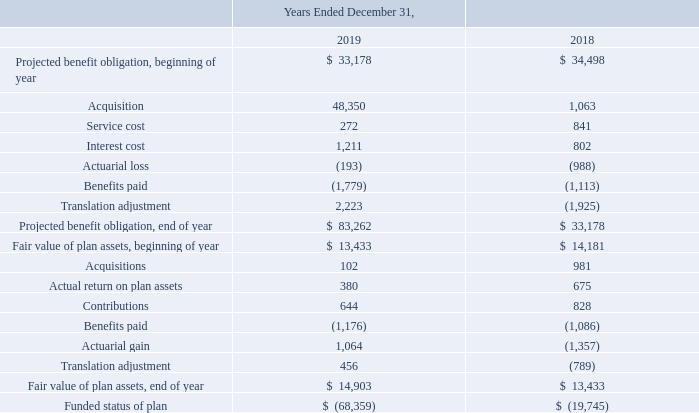Defined Benefit Plan
We maintain defined benefit pension plans for certain of our non-U.S. employees in the U.K., Germany, and Philippines. Each plan is managed locally and in accordance with respective local laws and regulations.
In order to measure the expense and related benefit obligation, various assumptions are made including discount rates used to value the obligation, expected return on plan assets used to fund these expenses and estimated future inflation rates. These assumptions are based on historical experience as well as facts and circumstances. An actuarial analysis is used to measure the expense and liability associated with pension benefits.
In connection with the acquisition of Artesyn in September of 2019, the Company acquired certain pension plans and, as a result, started including the related balances in its Consolidated Balance Sheets at December 31, 2019 and the expenses attributable to these plans for the period from September 10, 2019 to December 31, 2019 in its Consolidated Statement of Operations. See Note 2. Business Acquisitions for more details on this transaction.
ADVANCED ENERGY INDUSTRIES, INC. NOTES TO CONSOLIDATED FINANCIAL STATEMENTS – (continued) (in thousands, except per share amounts)
The information provided below includes one pension plan which is part of discontinued operations. As such, all related liabilities and expenses are reported in discontinued operations in the Company’s Consolidated Balance Sheets and Consolidated Statements of Operations for all periods presented.
The Company’s projected benefit obligation and plan assets for defined benefit pension plans at December 31, 2019 and 2018 and the related assumptions used to determine the related liabilities are as follows:
Where does the company report all related liabilities and expenses to discontinued operations? In discontinued operations in the company’s consolidated balance sheets and consolidated statements of operations for all periods presented. What was the acquisition in 2019?
Answer scale should be: thousand. 48,350. What was the service cost in 2018?
Answer scale should be: thousand. 841. What was the change in service cost between 2018 and 2019?
Answer scale should be: thousand. 272-841
Answer: -569. What was the change in interest cost between 2018 and 2019?
Answer scale should be: thousand. 1,211-802
Answer: 409. What was the percentage change in the fair value of plan assets, end of the year between 2018 and 2019?
Answer scale should be: percent. ($14,903-$13,433)/$13,433
Answer: 10.94. 